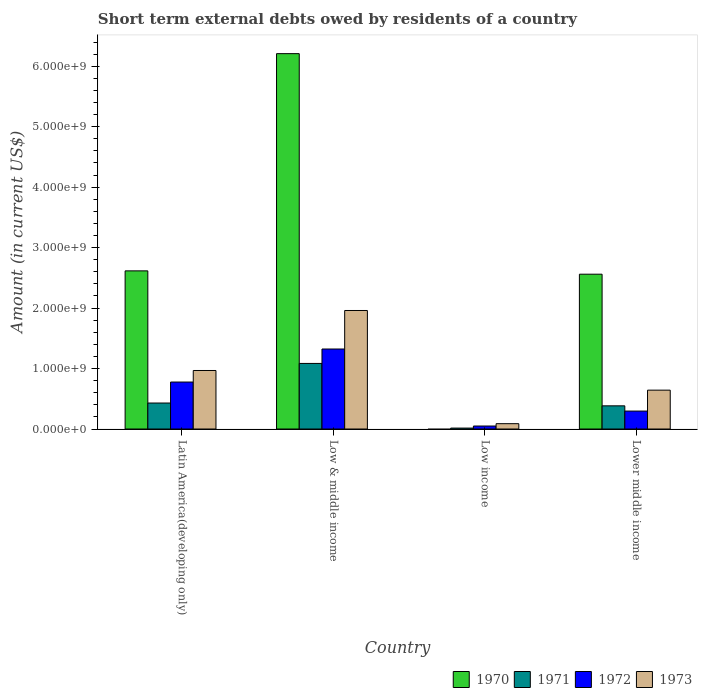How many different coloured bars are there?
Provide a short and direct response. 4. How many groups of bars are there?
Ensure brevity in your answer.  4. Are the number of bars per tick equal to the number of legend labels?
Keep it short and to the point. No. Are the number of bars on each tick of the X-axis equal?
Offer a very short reply. No. How many bars are there on the 4th tick from the left?
Keep it short and to the point. 4. What is the label of the 1st group of bars from the left?
Keep it short and to the point. Latin America(developing only). In how many cases, is the number of bars for a given country not equal to the number of legend labels?
Keep it short and to the point. 1. What is the amount of short-term external debts owed by residents in 1973 in Lower middle income?
Your answer should be very brief. 6.43e+08. Across all countries, what is the maximum amount of short-term external debts owed by residents in 1973?
Provide a succinct answer. 1.96e+09. Across all countries, what is the minimum amount of short-term external debts owed by residents in 1971?
Provide a short and direct response. 1.54e+07. What is the total amount of short-term external debts owed by residents in 1973 in the graph?
Give a very brief answer. 3.66e+09. What is the difference between the amount of short-term external debts owed by residents in 1970 in Latin America(developing only) and that in Low & middle income?
Offer a terse response. -3.59e+09. What is the difference between the amount of short-term external debts owed by residents in 1970 in Lower middle income and the amount of short-term external debts owed by residents in 1971 in Latin America(developing only)?
Your response must be concise. 2.13e+09. What is the average amount of short-term external debts owed by residents in 1972 per country?
Give a very brief answer. 6.12e+08. What is the difference between the amount of short-term external debts owed by residents of/in 1972 and amount of short-term external debts owed by residents of/in 1971 in Latin America(developing only)?
Offer a very short reply. 3.47e+08. In how many countries, is the amount of short-term external debts owed by residents in 1970 greater than 1600000000 US$?
Your response must be concise. 3. What is the ratio of the amount of short-term external debts owed by residents in 1970 in Low & middle income to that in Lower middle income?
Offer a terse response. 2.42. Is the difference between the amount of short-term external debts owed by residents in 1972 in Latin America(developing only) and Low & middle income greater than the difference between the amount of short-term external debts owed by residents in 1971 in Latin America(developing only) and Low & middle income?
Offer a very short reply. Yes. What is the difference between the highest and the second highest amount of short-term external debts owed by residents in 1970?
Your answer should be compact. 3.65e+09. What is the difference between the highest and the lowest amount of short-term external debts owed by residents in 1973?
Provide a succinct answer. 1.87e+09. In how many countries, is the amount of short-term external debts owed by residents in 1973 greater than the average amount of short-term external debts owed by residents in 1973 taken over all countries?
Ensure brevity in your answer.  2. Is the sum of the amount of short-term external debts owed by residents in 1972 in Low & middle income and Low income greater than the maximum amount of short-term external debts owed by residents in 1970 across all countries?
Your answer should be compact. No. How many bars are there?
Provide a succinct answer. 15. How many countries are there in the graph?
Give a very brief answer. 4. What is the difference between two consecutive major ticks on the Y-axis?
Offer a terse response. 1.00e+09. Does the graph contain any zero values?
Keep it short and to the point. Yes. How are the legend labels stacked?
Offer a terse response. Horizontal. What is the title of the graph?
Your answer should be compact. Short term external debts owed by residents of a country. What is the label or title of the Y-axis?
Offer a very short reply. Amount (in current US$). What is the Amount (in current US$) in 1970 in Latin America(developing only)?
Provide a short and direct response. 2.62e+09. What is the Amount (in current US$) of 1971 in Latin America(developing only)?
Make the answer very short. 4.30e+08. What is the Amount (in current US$) in 1972 in Latin America(developing only)?
Your response must be concise. 7.77e+08. What is the Amount (in current US$) of 1973 in Latin America(developing only)?
Ensure brevity in your answer.  9.68e+08. What is the Amount (in current US$) of 1970 in Low & middle income?
Give a very brief answer. 6.21e+09. What is the Amount (in current US$) of 1971 in Low & middle income?
Offer a very short reply. 1.08e+09. What is the Amount (in current US$) in 1972 in Low & middle income?
Make the answer very short. 1.32e+09. What is the Amount (in current US$) of 1973 in Low & middle income?
Offer a very short reply. 1.96e+09. What is the Amount (in current US$) in 1971 in Low income?
Provide a succinct answer. 1.54e+07. What is the Amount (in current US$) in 1972 in Low income?
Offer a very short reply. 4.94e+07. What is the Amount (in current US$) of 1973 in Low income?
Offer a very short reply. 8.84e+07. What is the Amount (in current US$) in 1970 in Lower middle income?
Provide a succinct answer. 2.56e+09. What is the Amount (in current US$) of 1971 in Lower middle income?
Provide a succinct answer. 3.83e+08. What is the Amount (in current US$) in 1972 in Lower middle income?
Offer a terse response. 2.97e+08. What is the Amount (in current US$) of 1973 in Lower middle income?
Offer a terse response. 6.43e+08. Across all countries, what is the maximum Amount (in current US$) of 1970?
Provide a short and direct response. 6.21e+09. Across all countries, what is the maximum Amount (in current US$) of 1971?
Your answer should be very brief. 1.08e+09. Across all countries, what is the maximum Amount (in current US$) of 1972?
Offer a terse response. 1.32e+09. Across all countries, what is the maximum Amount (in current US$) in 1973?
Your response must be concise. 1.96e+09. Across all countries, what is the minimum Amount (in current US$) of 1971?
Keep it short and to the point. 1.54e+07. Across all countries, what is the minimum Amount (in current US$) in 1972?
Ensure brevity in your answer.  4.94e+07. Across all countries, what is the minimum Amount (in current US$) in 1973?
Your response must be concise. 8.84e+07. What is the total Amount (in current US$) of 1970 in the graph?
Give a very brief answer. 1.14e+1. What is the total Amount (in current US$) of 1971 in the graph?
Provide a succinct answer. 1.91e+09. What is the total Amount (in current US$) of 1972 in the graph?
Keep it short and to the point. 2.45e+09. What is the total Amount (in current US$) of 1973 in the graph?
Ensure brevity in your answer.  3.66e+09. What is the difference between the Amount (in current US$) in 1970 in Latin America(developing only) and that in Low & middle income?
Offer a very short reply. -3.59e+09. What is the difference between the Amount (in current US$) of 1971 in Latin America(developing only) and that in Low & middle income?
Provide a short and direct response. -6.55e+08. What is the difference between the Amount (in current US$) of 1972 in Latin America(developing only) and that in Low & middle income?
Give a very brief answer. -5.46e+08. What is the difference between the Amount (in current US$) of 1973 in Latin America(developing only) and that in Low & middle income?
Offer a very short reply. -9.92e+08. What is the difference between the Amount (in current US$) in 1971 in Latin America(developing only) and that in Low income?
Your answer should be very brief. 4.15e+08. What is the difference between the Amount (in current US$) in 1972 in Latin America(developing only) and that in Low income?
Give a very brief answer. 7.28e+08. What is the difference between the Amount (in current US$) of 1973 in Latin America(developing only) and that in Low income?
Provide a short and direct response. 8.80e+08. What is the difference between the Amount (in current US$) in 1970 in Latin America(developing only) and that in Lower middle income?
Ensure brevity in your answer.  5.48e+07. What is the difference between the Amount (in current US$) of 1971 in Latin America(developing only) and that in Lower middle income?
Your response must be concise. 4.67e+07. What is the difference between the Amount (in current US$) in 1972 in Latin America(developing only) and that in Lower middle income?
Your response must be concise. 4.80e+08. What is the difference between the Amount (in current US$) of 1973 in Latin America(developing only) and that in Lower middle income?
Your answer should be compact. 3.25e+08. What is the difference between the Amount (in current US$) in 1971 in Low & middle income and that in Low income?
Make the answer very short. 1.07e+09. What is the difference between the Amount (in current US$) of 1972 in Low & middle income and that in Low income?
Offer a very short reply. 1.27e+09. What is the difference between the Amount (in current US$) in 1973 in Low & middle income and that in Low income?
Your answer should be compact. 1.87e+09. What is the difference between the Amount (in current US$) in 1970 in Low & middle income and that in Lower middle income?
Your answer should be compact. 3.65e+09. What is the difference between the Amount (in current US$) in 1971 in Low & middle income and that in Lower middle income?
Keep it short and to the point. 7.01e+08. What is the difference between the Amount (in current US$) of 1972 in Low & middle income and that in Lower middle income?
Provide a short and direct response. 1.03e+09. What is the difference between the Amount (in current US$) in 1973 in Low & middle income and that in Lower middle income?
Your answer should be very brief. 1.32e+09. What is the difference between the Amount (in current US$) in 1971 in Low income and that in Lower middle income?
Provide a short and direct response. -3.68e+08. What is the difference between the Amount (in current US$) in 1972 in Low income and that in Lower middle income?
Give a very brief answer. -2.47e+08. What is the difference between the Amount (in current US$) in 1973 in Low income and that in Lower middle income?
Offer a terse response. -5.54e+08. What is the difference between the Amount (in current US$) of 1970 in Latin America(developing only) and the Amount (in current US$) of 1971 in Low & middle income?
Give a very brief answer. 1.53e+09. What is the difference between the Amount (in current US$) in 1970 in Latin America(developing only) and the Amount (in current US$) in 1972 in Low & middle income?
Offer a terse response. 1.29e+09. What is the difference between the Amount (in current US$) of 1970 in Latin America(developing only) and the Amount (in current US$) of 1973 in Low & middle income?
Provide a succinct answer. 6.55e+08. What is the difference between the Amount (in current US$) of 1971 in Latin America(developing only) and the Amount (in current US$) of 1972 in Low & middle income?
Your answer should be very brief. -8.93e+08. What is the difference between the Amount (in current US$) in 1971 in Latin America(developing only) and the Amount (in current US$) in 1973 in Low & middle income?
Make the answer very short. -1.53e+09. What is the difference between the Amount (in current US$) in 1972 in Latin America(developing only) and the Amount (in current US$) in 1973 in Low & middle income?
Provide a succinct answer. -1.18e+09. What is the difference between the Amount (in current US$) in 1970 in Latin America(developing only) and the Amount (in current US$) in 1971 in Low income?
Your answer should be very brief. 2.60e+09. What is the difference between the Amount (in current US$) of 1970 in Latin America(developing only) and the Amount (in current US$) of 1972 in Low income?
Give a very brief answer. 2.57e+09. What is the difference between the Amount (in current US$) of 1970 in Latin America(developing only) and the Amount (in current US$) of 1973 in Low income?
Offer a terse response. 2.53e+09. What is the difference between the Amount (in current US$) of 1971 in Latin America(developing only) and the Amount (in current US$) of 1972 in Low income?
Your answer should be very brief. 3.81e+08. What is the difference between the Amount (in current US$) in 1971 in Latin America(developing only) and the Amount (in current US$) in 1973 in Low income?
Make the answer very short. 3.42e+08. What is the difference between the Amount (in current US$) in 1972 in Latin America(developing only) and the Amount (in current US$) in 1973 in Low income?
Keep it short and to the point. 6.89e+08. What is the difference between the Amount (in current US$) of 1970 in Latin America(developing only) and the Amount (in current US$) of 1971 in Lower middle income?
Ensure brevity in your answer.  2.23e+09. What is the difference between the Amount (in current US$) in 1970 in Latin America(developing only) and the Amount (in current US$) in 1972 in Lower middle income?
Your response must be concise. 2.32e+09. What is the difference between the Amount (in current US$) of 1970 in Latin America(developing only) and the Amount (in current US$) of 1973 in Lower middle income?
Your response must be concise. 1.97e+09. What is the difference between the Amount (in current US$) of 1971 in Latin America(developing only) and the Amount (in current US$) of 1972 in Lower middle income?
Offer a very short reply. 1.33e+08. What is the difference between the Amount (in current US$) of 1971 in Latin America(developing only) and the Amount (in current US$) of 1973 in Lower middle income?
Your response must be concise. -2.13e+08. What is the difference between the Amount (in current US$) of 1972 in Latin America(developing only) and the Amount (in current US$) of 1973 in Lower middle income?
Give a very brief answer. 1.34e+08. What is the difference between the Amount (in current US$) in 1970 in Low & middle income and the Amount (in current US$) in 1971 in Low income?
Offer a terse response. 6.19e+09. What is the difference between the Amount (in current US$) of 1970 in Low & middle income and the Amount (in current US$) of 1972 in Low income?
Ensure brevity in your answer.  6.16e+09. What is the difference between the Amount (in current US$) in 1970 in Low & middle income and the Amount (in current US$) in 1973 in Low income?
Make the answer very short. 6.12e+09. What is the difference between the Amount (in current US$) of 1971 in Low & middle income and the Amount (in current US$) of 1972 in Low income?
Keep it short and to the point. 1.04e+09. What is the difference between the Amount (in current US$) of 1971 in Low & middle income and the Amount (in current US$) of 1973 in Low income?
Give a very brief answer. 9.96e+08. What is the difference between the Amount (in current US$) in 1972 in Low & middle income and the Amount (in current US$) in 1973 in Low income?
Offer a terse response. 1.23e+09. What is the difference between the Amount (in current US$) of 1970 in Low & middle income and the Amount (in current US$) of 1971 in Lower middle income?
Your response must be concise. 5.83e+09. What is the difference between the Amount (in current US$) in 1970 in Low & middle income and the Amount (in current US$) in 1972 in Lower middle income?
Keep it short and to the point. 5.91e+09. What is the difference between the Amount (in current US$) of 1970 in Low & middle income and the Amount (in current US$) of 1973 in Lower middle income?
Your response must be concise. 5.57e+09. What is the difference between the Amount (in current US$) of 1971 in Low & middle income and the Amount (in current US$) of 1972 in Lower middle income?
Provide a short and direct response. 7.88e+08. What is the difference between the Amount (in current US$) in 1971 in Low & middle income and the Amount (in current US$) in 1973 in Lower middle income?
Provide a short and direct response. 4.42e+08. What is the difference between the Amount (in current US$) in 1972 in Low & middle income and the Amount (in current US$) in 1973 in Lower middle income?
Ensure brevity in your answer.  6.80e+08. What is the difference between the Amount (in current US$) of 1971 in Low income and the Amount (in current US$) of 1972 in Lower middle income?
Give a very brief answer. -2.81e+08. What is the difference between the Amount (in current US$) of 1971 in Low income and the Amount (in current US$) of 1973 in Lower middle income?
Offer a very short reply. -6.27e+08. What is the difference between the Amount (in current US$) of 1972 in Low income and the Amount (in current US$) of 1973 in Lower middle income?
Make the answer very short. -5.93e+08. What is the average Amount (in current US$) in 1970 per country?
Keep it short and to the point. 2.85e+09. What is the average Amount (in current US$) in 1971 per country?
Keep it short and to the point. 4.78e+08. What is the average Amount (in current US$) in 1972 per country?
Offer a terse response. 6.12e+08. What is the average Amount (in current US$) in 1973 per country?
Give a very brief answer. 9.15e+08. What is the difference between the Amount (in current US$) in 1970 and Amount (in current US$) in 1971 in Latin America(developing only)?
Provide a succinct answer. 2.19e+09. What is the difference between the Amount (in current US$) in 1970 and Amount (in current US$) in 1972 in Latin America(developing only)?
Offer a terse response. 1.84e+09. What is the difference between the Amount (in current US$) in 1970 and Amount (in current US$) in 1973 in Latin America(developing only)?
Offer a very short reply. 1.65e+09. What is the difference between the Amount (in current US$) of 1971 and Amount (in current US$) of 1972 in Latin America(developing only)?
Your response must be concise. -3.47e+08. What is the difference between the Amount (in current US$) in 1971 and Amount (in current US$) in 1973 in Latin America(developing only)?
Offer a terse response. -5.38e+08. What is the difference between the Amount (in current US$) in 1972 and Amount (in current US$) in 1973 in Latin America(developing only)?
Your answer should be very brief. -1.91e+08. What is the difference between the Amount (in current US$) in 1970 and Amount (in current US$) in 1971 in Low & middle income?
Offer a terse response. 5.12e+09. What is the difference between the Amount (in current US$) in 1970 and Amount (in current US$) in 1972 in Low & middle income?
Make the answer very short. 4.89e+09. What is the difference between the Amount (in current US$) in 1970 and Amount (in current US$) in 1973 in Low & middle income?
Give a very brief answer. 4.25e+09. What is the difference between the Amount (in current US$) in 1971 and Amount (in current US$) in 1972 in Low & middle income?
Your answer should be very brief. -2.39e+08. What is the difference between the Amount (in current US$) of 1971 and Amount (in current US$) of 1973 in Low & middle income?
Give a very brief answer. -8.76e+08. What is the difference between the Amount (in current US$) in 1972 and Amount (in current US$) in 1973 in Low & middle income?
Make the answer very short. -6.37e+08. What is the difference between the Amount (in current US$) in 1971 and Amount (in current US$) in 1972 in Low income?
Your response must be concise. -3.40e+07. What is the difference between the Amount (in current US$) in 1971 and Amount (in current US$) in 1973 in Low income?
Give a very brief answer. -7.30e+07. What is the difference between the Amount (in current US$) of 1972 and Amount (in current US$) of 1973 in Low income?
Provide a succinct answer. -3.90e+07. What is the difference between the Amount (in current US$) in 1970 and Amount (in current US$) in 1971 in Lower middle income?
Provide a short and direct response. 2.18e+09. What is the difference between the Amount (in current US$) in 1970 and Amount (in current US$) in 1972 in Lower middle income?
Your answer should be very brief. 2.26e+09. What is the difference between the Amount (in current US$) of 1970 and Amount (in current US$) of 1973 in Lower middle income?
Your answer should be very brief. 1.92e+09. What is the difference between the Amount (in current US$) in 1971 and Amount (in current US$) in 1972 in Lower middle income?
Your response must be concise. 8.65e+07. What is the difference between the Amount (in current US$) of 1971 and Amount (in current US$) of 1973 in Lower middle income?
Offer a terse response. -2.60e+08. What is the difference between the Amount (in current US$) in 1972 and Amount (in current US$) in 1973 in Lower middle income?
Offer a terse response. -3.46e+08. What is the ratio of the Amount (in current US$) in 1970 in Latin America(developing only) to that in Low & middle income?
Your response must be concise. 0.42. What is the ratio of the Amount (in current US$) in 1971 in Latin America(developing only) to that in Low & middle income?
Provide a succinct answer. 0.4. What is the ratio of the Amount (in current US$) in 1972 in Latin America(developing only) to that in Low & middle income?
Make the answer very short. 0.59. What is the ratio of the Amount (in current US$) in 1973 in Latin America(developing only) to that in Low & middle income?
Make the answer very short. 0.49. What is the ratio of the Amount (in current US$) of 1971 in Latin America(developing only) to that in Low income?
Your answer should be very brief. 28.01. What is the ratio of the Amount (in current US$) of 1972 in Latin America(developing only) to that in Low income?
Keep it short and to the point. 15.74. What is the ratio of the Amount (in current US$) in 1973 in Latin America(developing only) to that in Low income?
Offer a terse response. 10.96. What is the ratio of the Amount (in current US$) of 1970 in Latin America(developing only) to that in Lower middle income?
Keep it short and to the point. 1.02. What is the ratio of the Amount (in current US$) in 1971 in Latin America(developing only) to that in Lower middle income?
Offer a terse response. 1.12. What is the ratio of the Amount (in current US$) in 1972 in Latin America(developing only) to that in Lower middle income?
Keep it short and to the point. 2.62. What is the ratio of the Amount (in current US$) of 1973 in Latin America(developing only) to that in Lower middle income?
Provide a short and direct response. 1.51. What is the ratio of the Amount (in current US$) of 1971 in Low & middle income to that in Low income?
Give a very brief answer. 70.65. What is the ratio of the Amount (in current US$) of 1972 in Low & middle income to that in Low income?
Offer a very short reply. 26.81. What is the ratio of the Amount (in current US$) in 1973 in Low & middle income to that in Low income?
Provide a succinct answer. 22.19. What is the ratio of the Amount (in current US$) in 1970 in Low & middle income to that in Lower middle income?
Offer a very short reply. 2.42. What is the ratio of the Amount (in current US$) in 1971 in Low & middle income to that in Lower middle income?
Give a very brief answer. 2.83. What is the ratio of the Amount (in current US$) in 1972 in Low & middle income to that in Lower middle income?
Your response must be concise. 4.46. What is the ratio of the Amount (in current US$) in 1973 in Low & middle income to that in Lower middle income?
Ensure brevity in your answer.  3.05. What is the ratio of the Amount (in current US$) in 1971 in Low income to that in Lower middle income?
Provide a succinct answer. 0.04. What is the ratio of the Amount (in current US$) of 1972 in Low income to that in Lower middle income?
Offer a very short reply. 0.17. What is the ratio of the Amount (in current US$) of 1973 in Low income to that in Lower middle income?
Offer a terse response. 0.14. What is the difference between the highest and the second highest Amount (in current US$) of 1970?
Offer a terse response. 3.59e+09. What is the difference between the highest and the second highest Amount (in current US$) of 1971?
Your answer should be compact. 6.55e+08. What is the difference between the highest and the second highest Amount (in current US$) of 1972?
Give a very brief answer. 5.46e+08. What is the difference between the highest and the second highest Amount (in current US$) in 1973?
Ensure brevity in your answer.  9.92e+08. What is the difference between the highest and the lowest Amount (in current US$) in 1970?
Keep it short and to the point. 6.21e+09. What is the difference between the highest and the lowest Amount (in current US$) in 1971?
Give a very brief answer. 1.07e+09. What is the difference between the highest and the lowest Amount (in current US$) of 1972?
Ensure brevity in your answer.  1.27e+09. What is the difference between the highest and the lowest Amount (in current US$) in 1973?
Your answer should be very brief. 1.87e+09. 